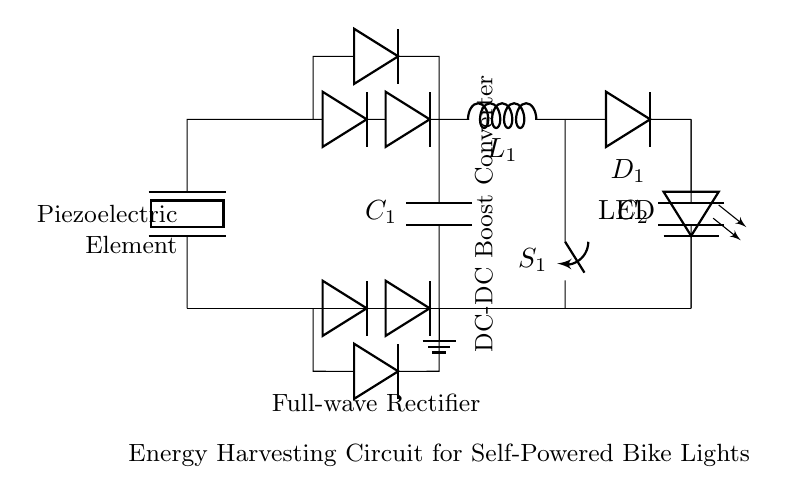What is the main component providing energy in this circuit? The main component is the piezoelectric element, which converts mechanical energy into electrical energy.
Answer: Piezoelectric element What type of rectifier is used in this circuit? A full-wave rectifier is indicated by the arrangement of four diodes that convert AC from the piezoelectric element into DC.
Answer: Full-wave rectifier What is the purpose of the capacitor labeled C1? C1 smooths the output voltage from the rectifier, reducing voltage fluctuations and providing a more stable DC voltage.
Answer: Smoothing How many diodes are present in the circuit? There are four diodes in total, utilized in the full-wave rectifier part of the circuit.
Answer: Four What component is used to boost the voltage in this circuit? The inductor labeled L1 works in conjunction with the other components to step up the voltage in the DC-DC boost converter section.
Answer: Inductor What is the load connected to the circuit? The load connected to the circuit is an LED that illuminates when sufficient voltage is provided by the energy harvesting system.
Answer: LED What is the role of the switch labeled S1? Switch S1 controls the connection between the inductor and the rest of the circuit, managing the operation of the DC-DC boost converter.
Answer: Control 